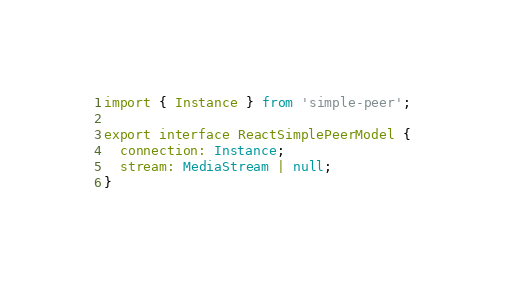<code> <loc_0><loc_0><loc_500><loc_500><_TypeScript_>import { Instance } from 'simple-peer';

export interface ReactSimplePeerModel {
  connection: Instance;
  stream: MediaStream | null;
}
</code> 